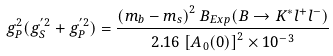Convert formula to latex. <formula><loc_0><loc_0><loc_500><loc_500>g _ { P } ^ { 2 } ( g _ { S } ^ { ^ { \prime } 2 } + g _ { P } ^ { ^ { \prime } 2 } ) = \frac { \left ( m _ { b } - m _ { s } \right ) ^ { 2 } B _ { E x p } ( B \rightarrow K ^ { * } l ^ { + } l ^ { - } ) } { 2 . 1 6 \left [ A _ { 0 } ( 0 ) \right ] ^ { 2 } \times 1 0 ^ { - 3 } }</formula> 